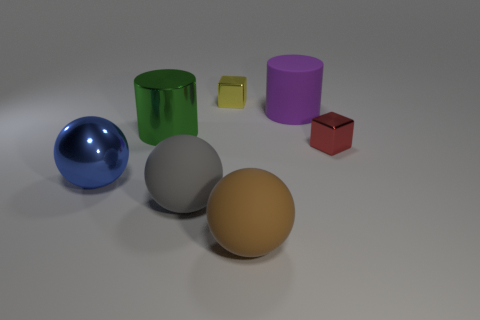Add 1 large blue cylinders. How many objects exist? 8 Subtract all brown spheres. How many spheres are left? 2 Subtract all blue cylinders. Subtract all red balls. How many cylinders are left? 2 Subtract all cyan blocks. How many cyan cylinders are left? 0 Subtract all big gray spheres. Subtract all red cubes. How many objects are left? 5 Add 5 gray spheres. How many gray spheres are left? 6 Add 5 tiny red metallic blocks. How many tiny red metallic blocks exist? 6 Subtract all brown balls. How many balls are left? 2 Subtract 0 red spheres. How many objects are left? 7 Subtract all cylinders. How many objects are left? 5 